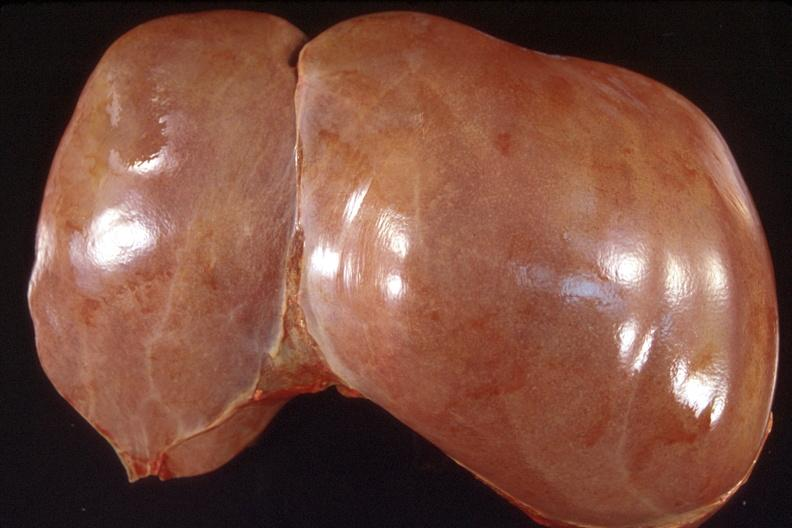what is present?
Answer the question using a single word or phrase. Hepatobiliary 